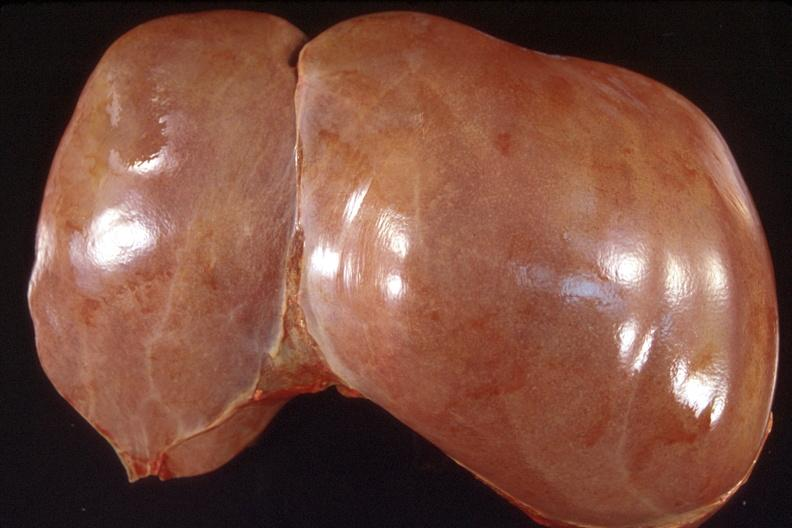what is present?
Answer the question using a single word or phrase. Hepatobiliary 